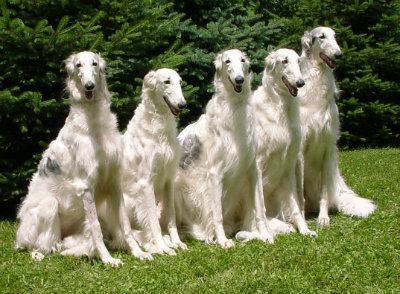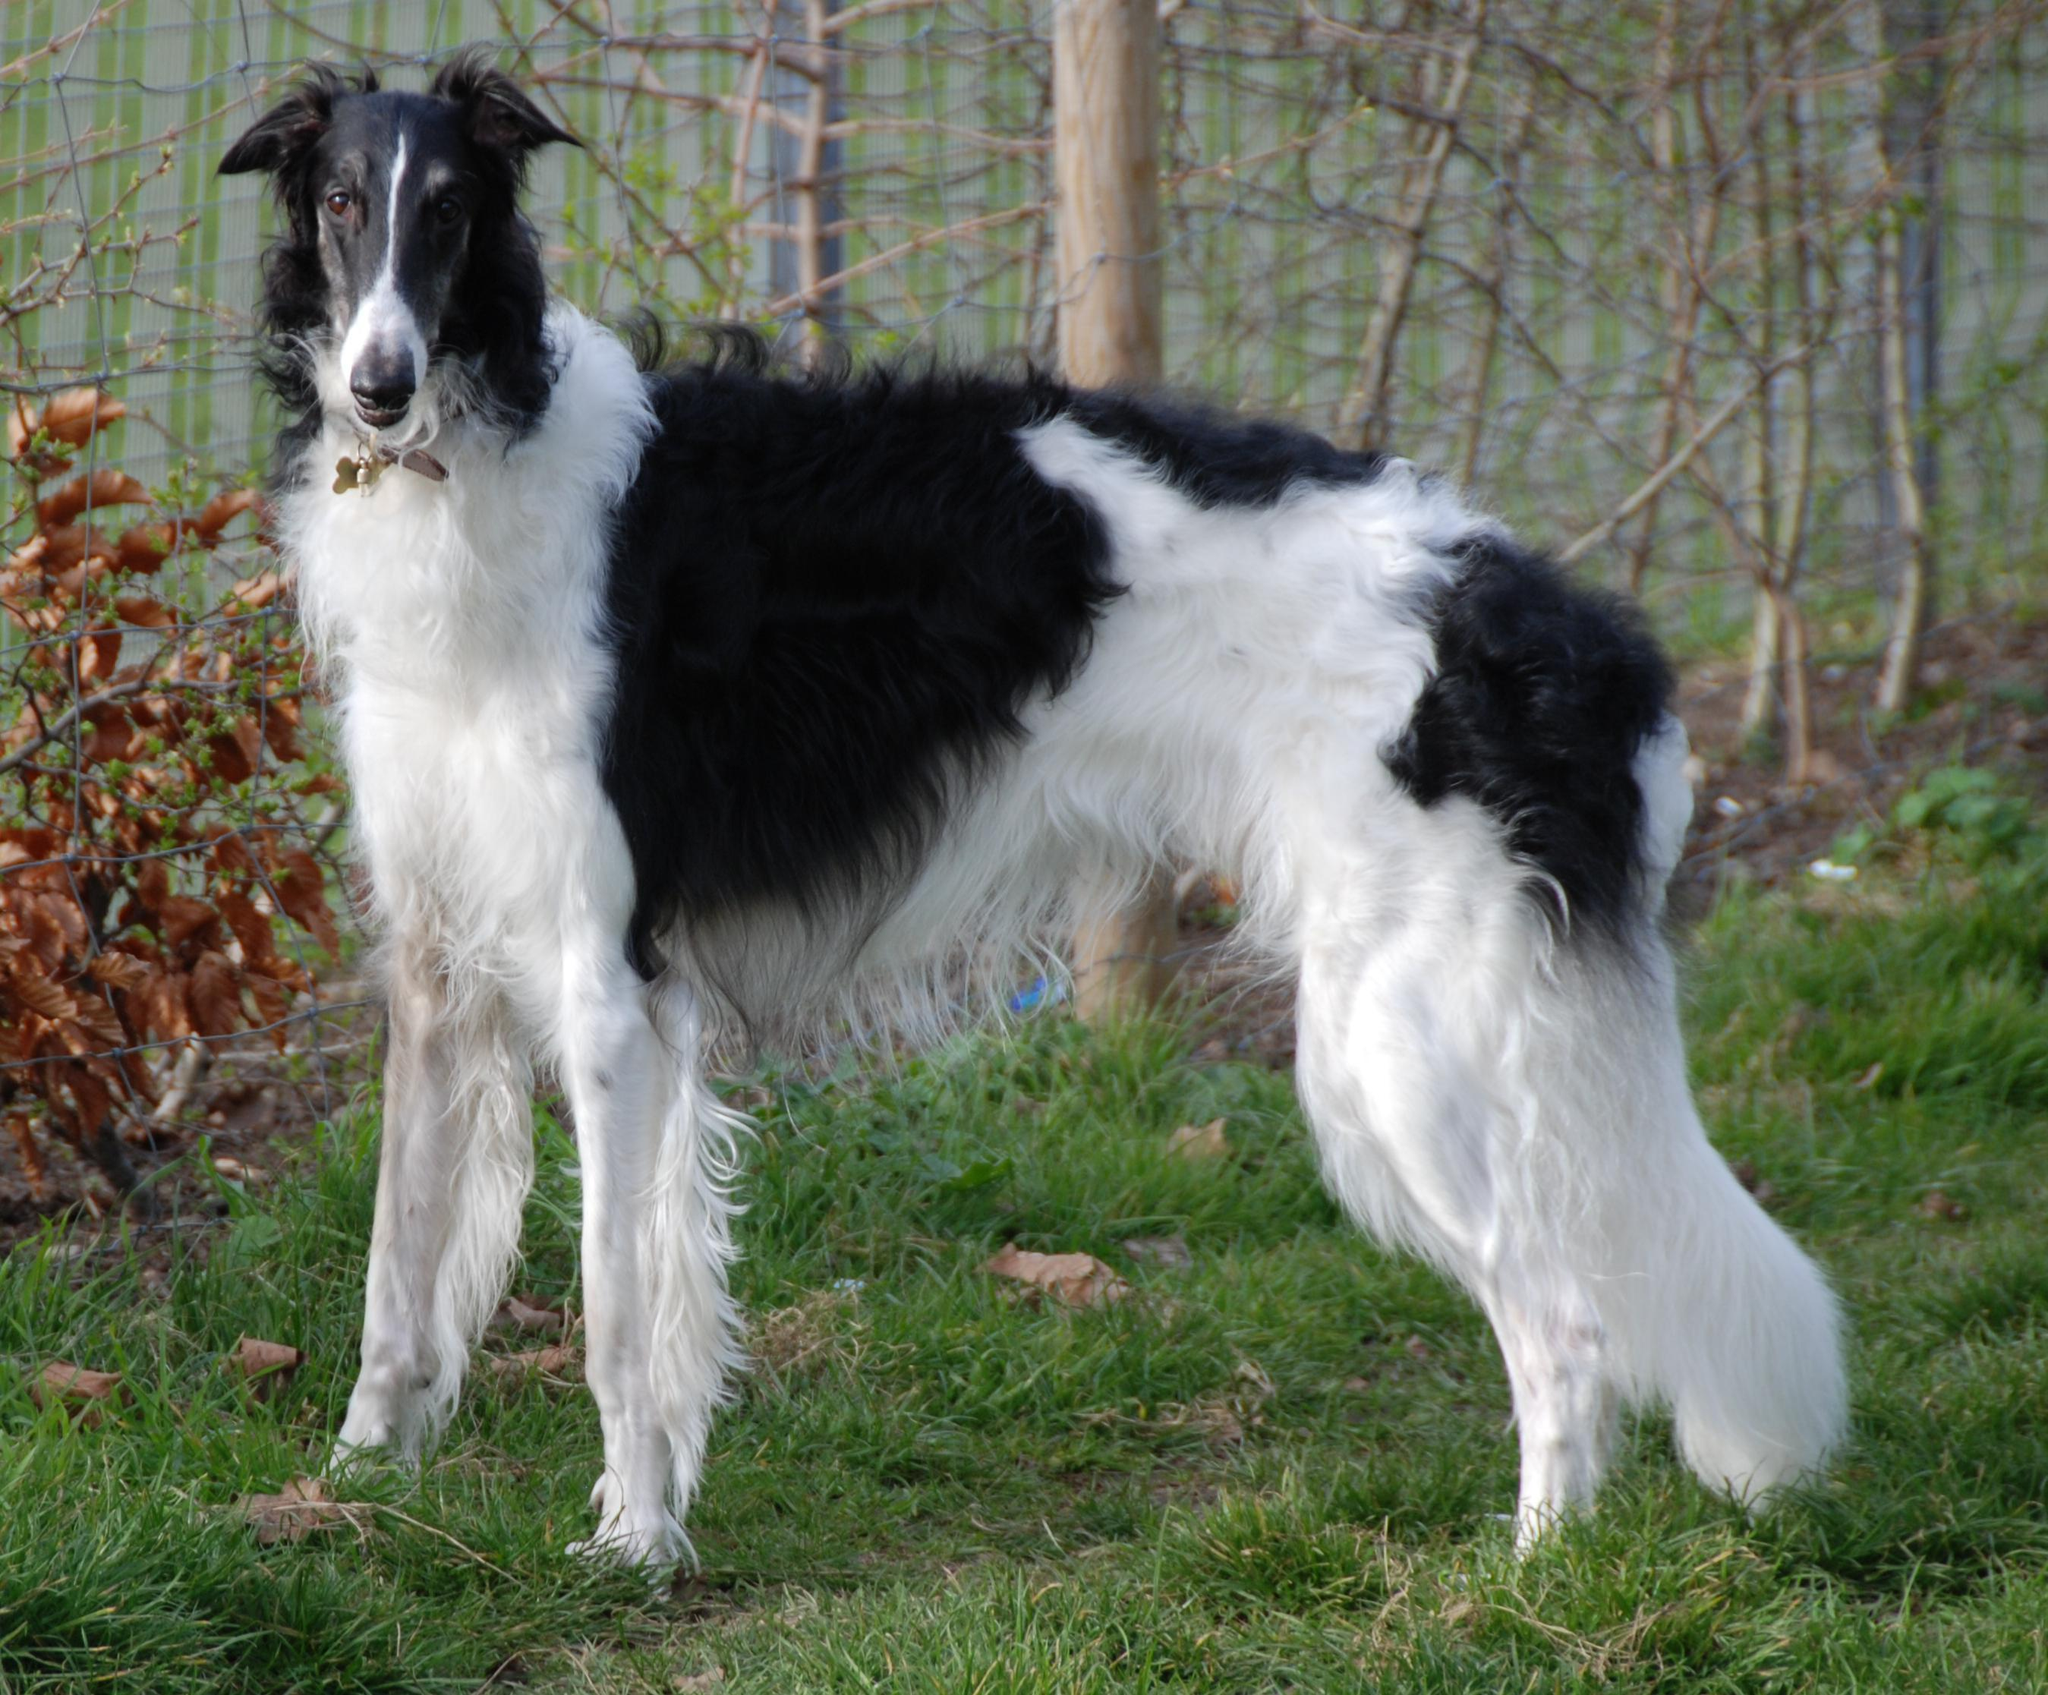The first image is the image on the left, the second image is the image on the right. For the images shown, is this caption "There are exactly four dogs in each set of images." true? Answer yes or no. No. The first image is the image on the left, the second image is the image on the right. Examine the images to the left and right. Is the description "There are two dogs in the left image." accurate? Answer yes or no. No. The first image is the image on the left, the second image is the image on the right. Given the left and right images, does the statement "An image shows exactly two hounds." hold true? Answer yes or no. No. 